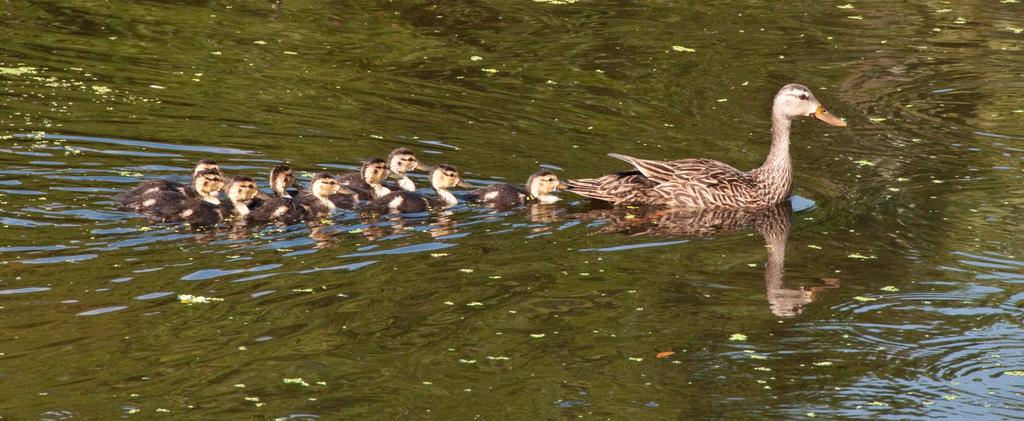What type of animal is present in the image? There is a duck in the image. Are there any other animals related to the duck in the image? Yes, there are ducklings in the image. Where are the duck and ducklings located? The duck and ducklings are on the water. What is the opinion of the duck about the ocean in the image? There is no indication of the duck's opinion about the ocean in the image, as the image does not depict an ocean. 